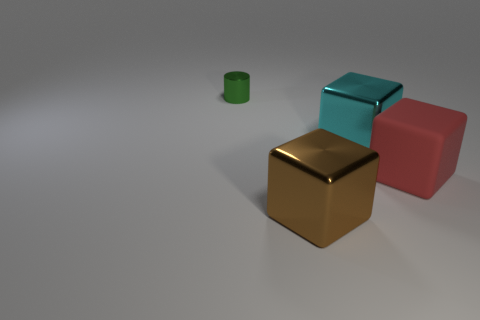There is a brown metallic object that is the same size as the red thing; what is its shape?
Keep it short and to the point. Cube. What number of large rubber cubes have the same color as the big rubber object?
Make the answer very short. 0. There is a cube that is in front of the big rubber object; what size is it?
Your answer should be very brief. Large. How many green metal objects have the same size as the green metallic cylinder?
Your answer should be very brief. 0. The other small thing that is made of the same material as the brown thing is what color?
Your response must be concise. Green. Are there fewer small green shiny objects to the right of the big red matte object than large cyan metal things?
Your response must be concise. Yes. What shape is the green thing that is the same material as the brown object?
Make the answer very short. Cylinder. How many rubber objects are either brown objects or cyan cubes?
Your answer should be compact. 0. Are there an equal number of tiny green metal things that are behind the tiny shiny thing and tiny purple cubes?
Provide a succinct answer. Yes. There is a large metal thing in front of the large cyan cube; does it have the same color as the small object?
Keep it short and to the point. No. 